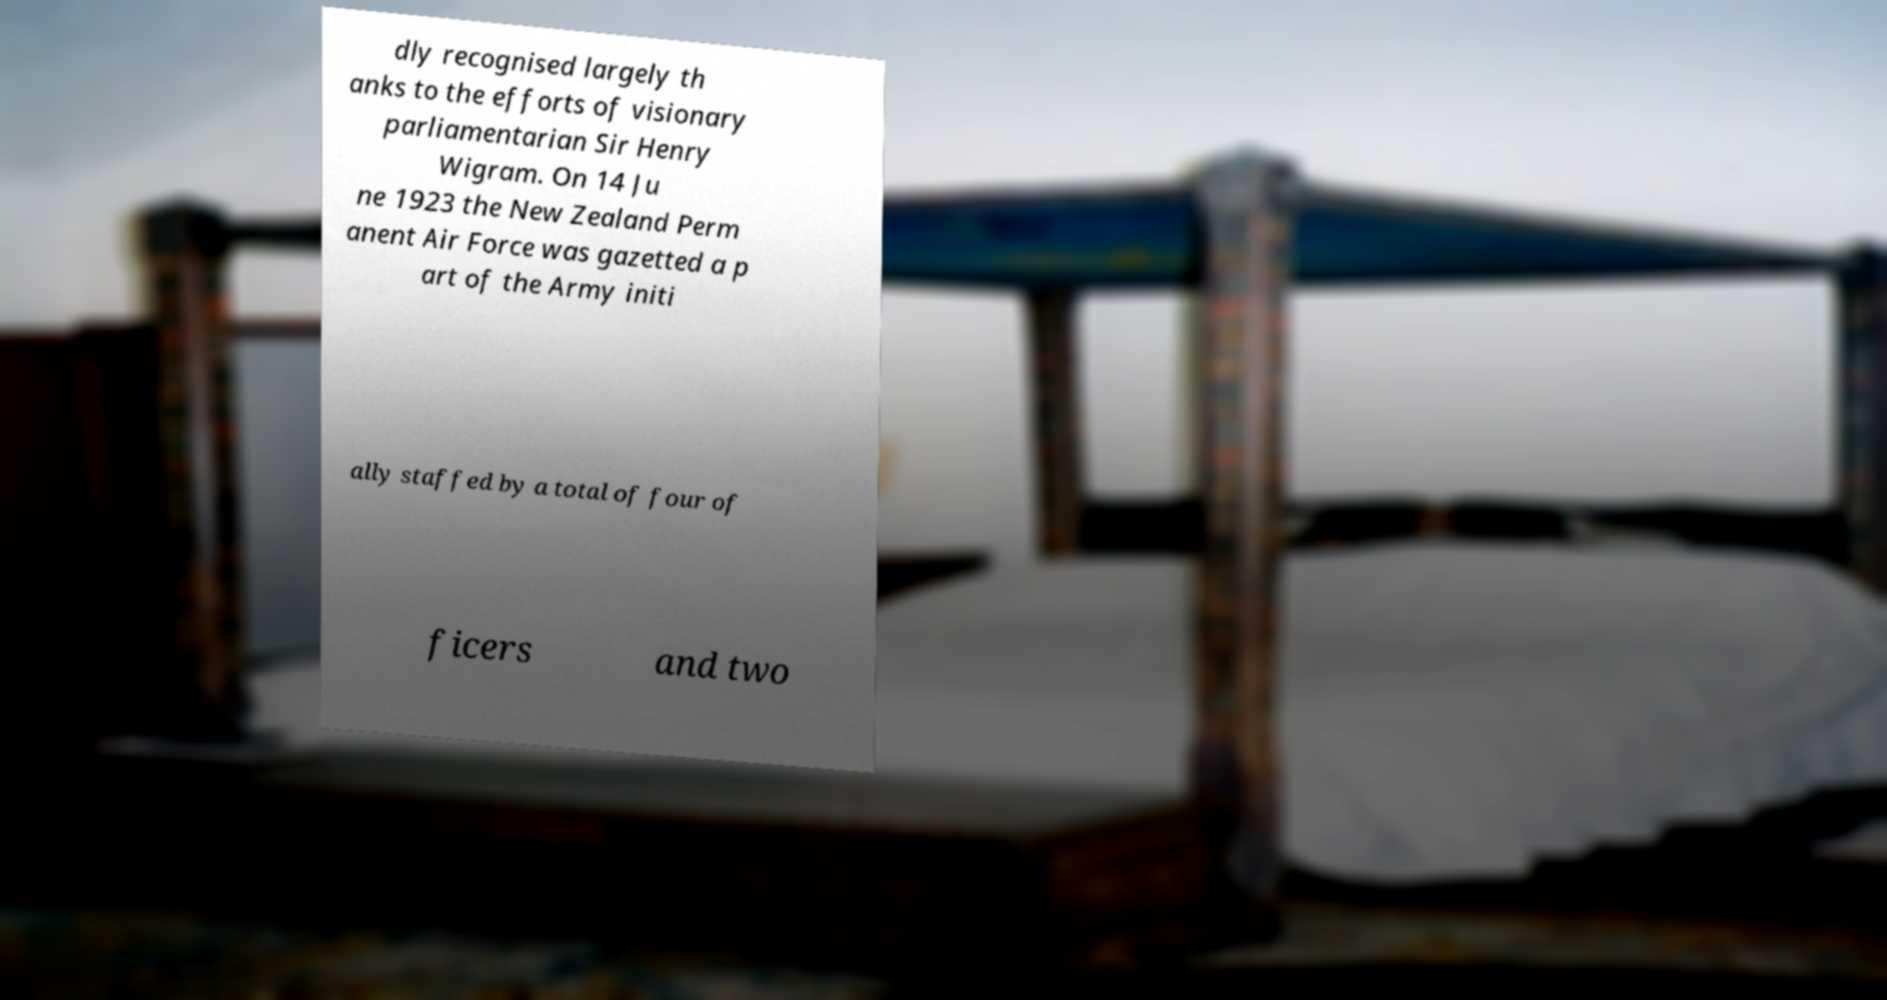Could you assist in decoding the text presented in this image and type it out clearly? dly recognised largely th anks to the efforts of visionary parliamentarian Sir Henry Wigram. On 14 Ju ne 1923 the New Zealand Perm anent Air Force was gazetted a p art of the Army initi ally staffed by a total of four of ficers and two 